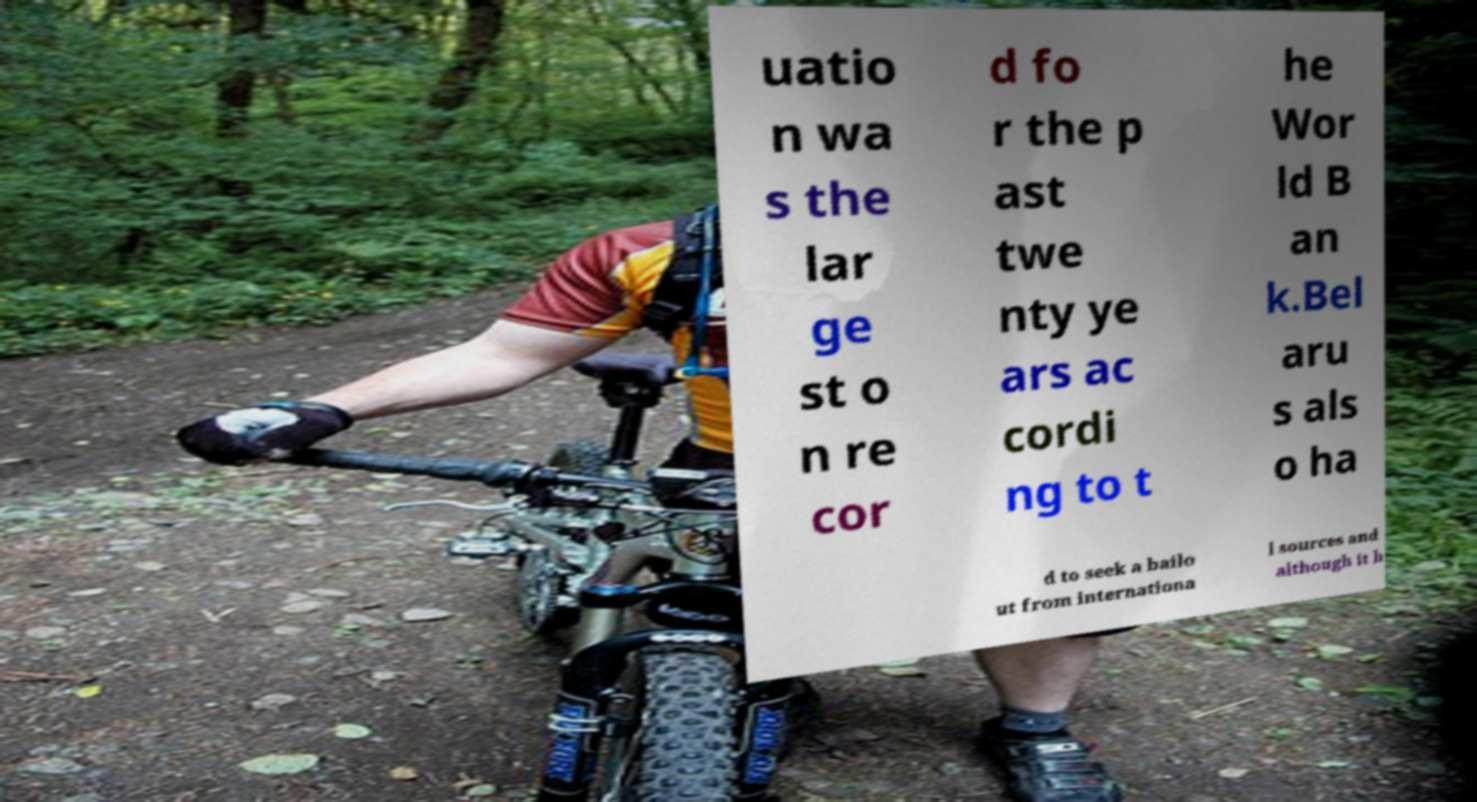Please identify and transcribe the text found in this image. uatio n wa s the lar ge st o n re cor d fo r the p ast twe nty ye ars ac cordi ng to t he Wor ld B an k.Bel aru s als o ha d to seek a bailo ut from internationa l sources and although it h 